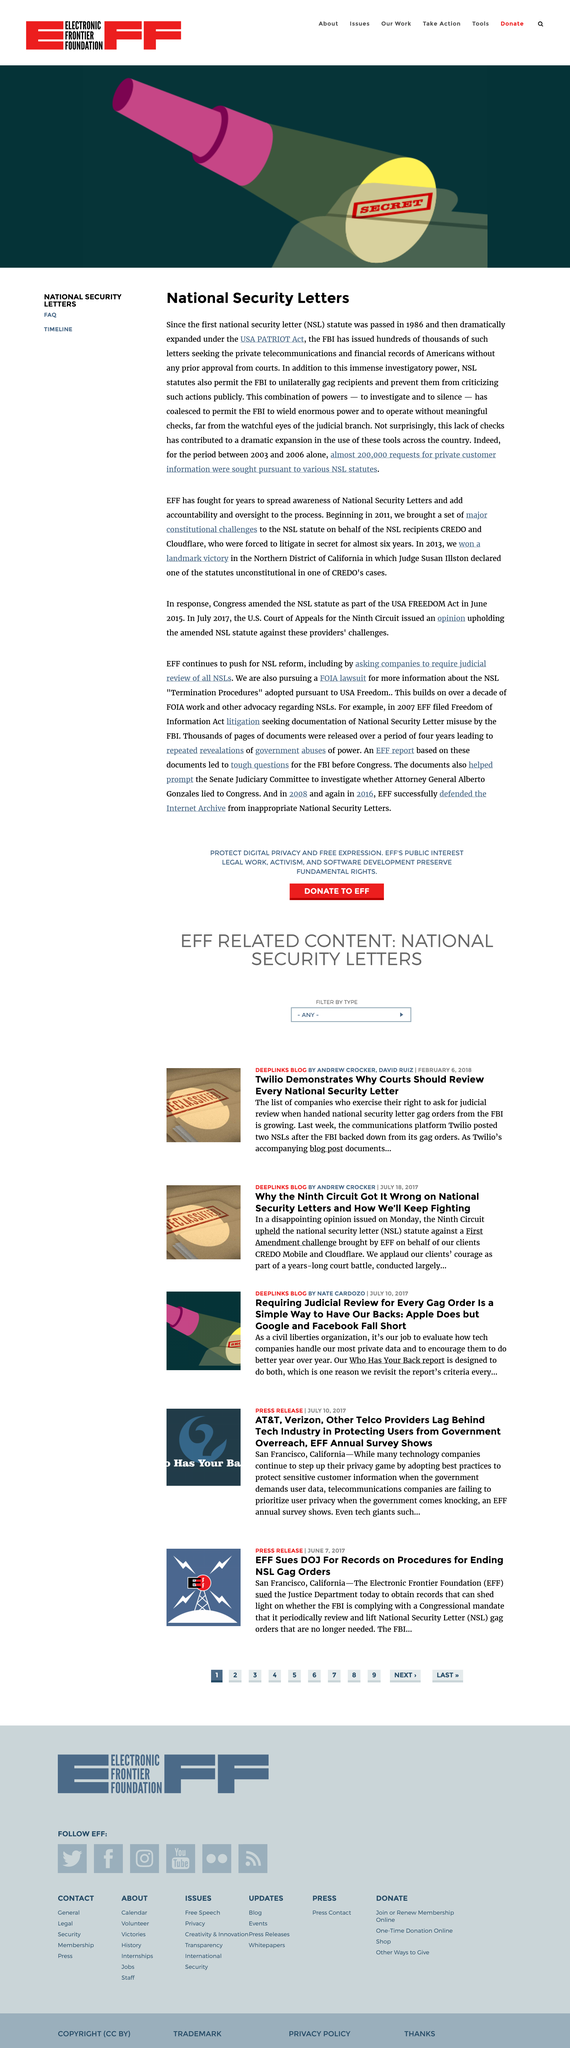Draw attention to some important aspects in this diagram. During the period of 2003 to 2006, almost 200,000 requests for private customer information were made. The USA PATRIOT Act was expanded under a specific Act. NSL stands for National Security Letter, a tool used by law enforcement agencies to gather information about individuals in the interest of national security. 